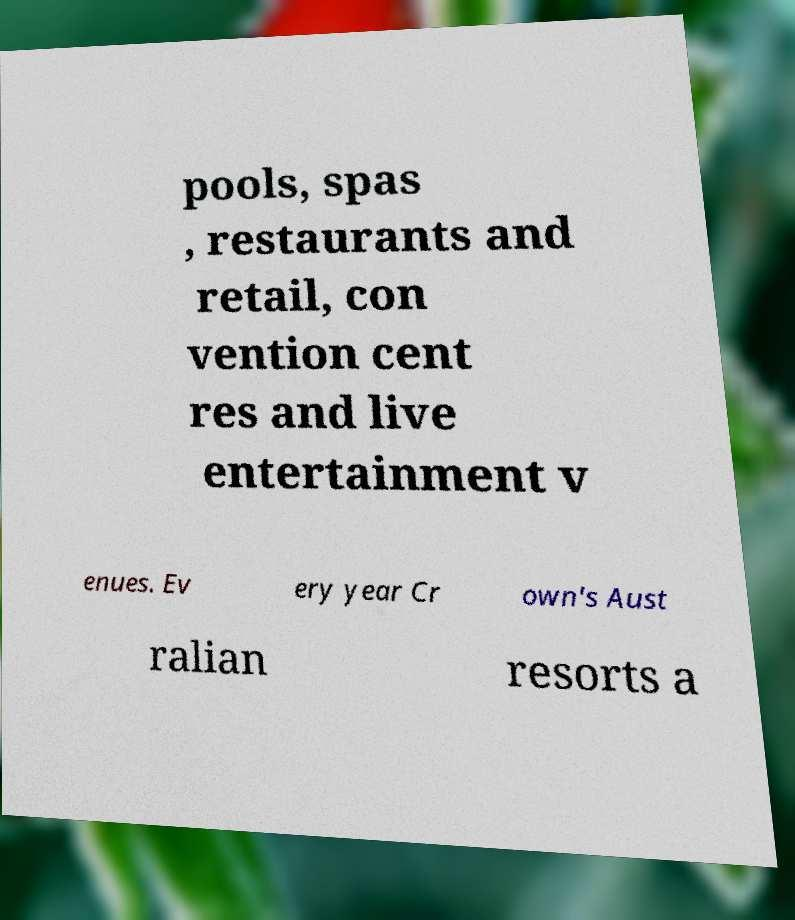I need the written content from this picture converted into text. Can you do that? pools, spas , restaurants and retail, con vention cent res and live entertainment v enues. Ev ery year Cr own's Aust ralian resorts a 